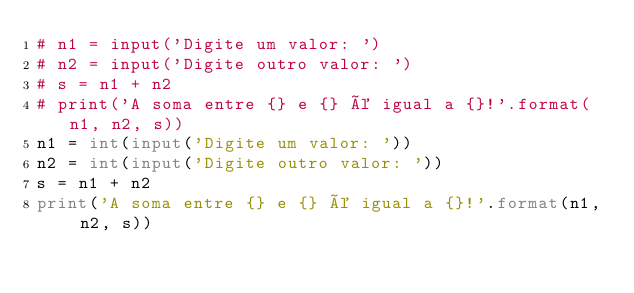Convert code to text. <code><loc_0><loc_0><loc_500><loc_500><_Python_># n1 = input('Digite um valor: ')
# n2 = input('Digite outro valor: ')
# s = n1 + n2
# print('A soma entre {} e {} é igual a {}!'.format(n1, n2, s))
n1 = int(input('Digite um valor: '))
n2 = int(input('Digite outro valor: '))
s = n1 + n2
print('A soma entre {} e {} é igual a {}!'.format(n1, n2, s))</code> 